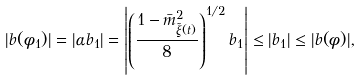Convert formula to latex. <formula><loc_0><loc_0><loc_500><loc_500>| b ( \phi _ { 1 } ) | = | \alpha b _ { 1 } | = \left | \left ( \frac { 1 - \bar { m } _ { \tilde { \xi } ( t ) } ^ { 2 } } { 8 } \right ) ^ { 1 / 2 } b _ { 1 } \right | \leq | b _ { 1 } | \leq | b ( \phi ) | ,</formula> 